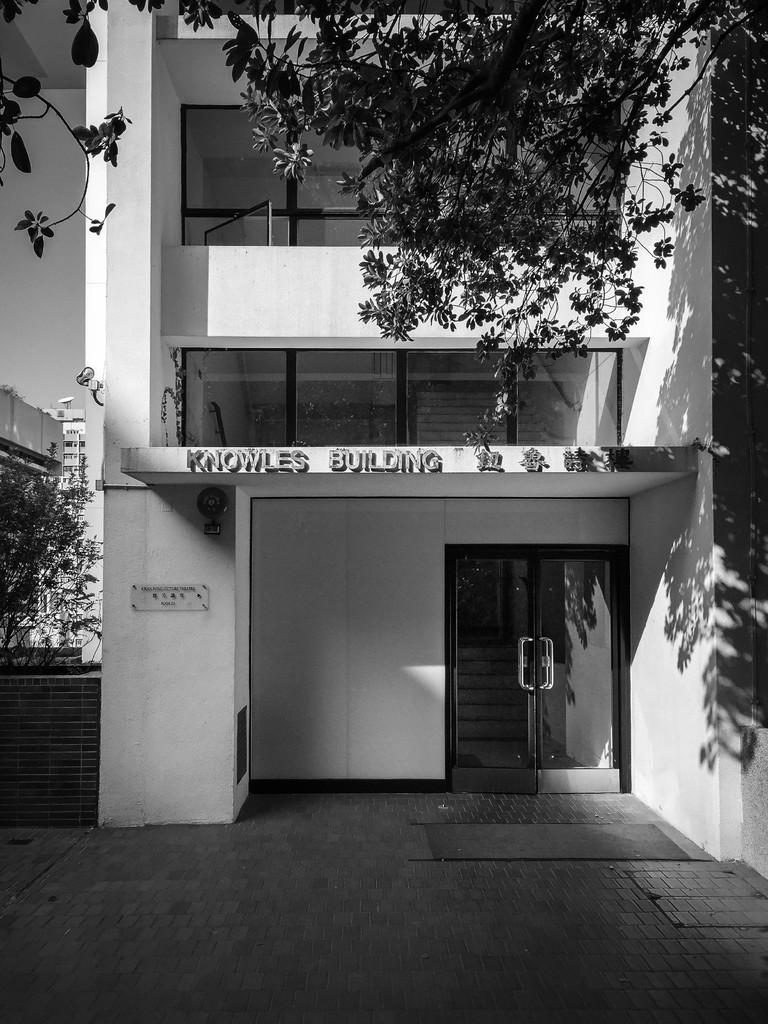Please provide a concise description of this image. This is a black and white picture. Here we can see buildings, door, board, trees, and glass. Here we can see sky. 